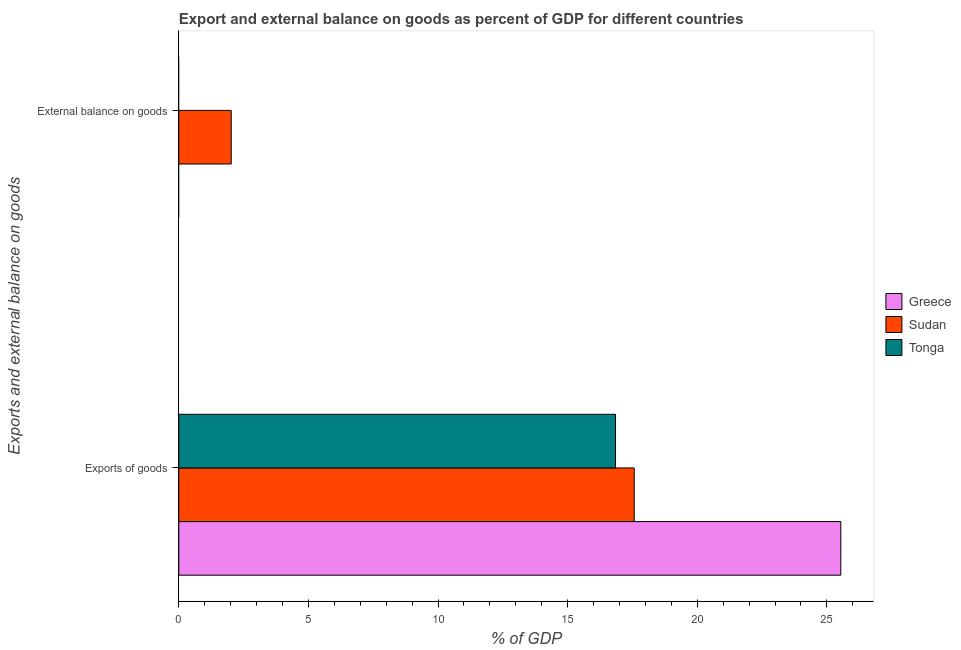Are the number of bars per tick equal to the number of legend labels?
Offer a very short reply. No. How many bars are there on the 2nd tick from the top?
Provide a short and direct response. 3. How many bars are there on the 1st tick from the bottom?
Give a very brief answer. 3. What is the label of the 1st group of bars from the top?
Keep it short and to the point. External balance on goods. What is the external balance on goods as percentage of gdp in Sudan?
Your answer should be very brief. 2.02. Across all countries, what is the maximum external balance on goods as percentage of gdp?
Make the answer very short. 2.02. Across all countries, what is the minimum export of goods as percentage of gdp?
Your answer should be compact. 16.85. In which country was the export of goods as percentage of gdp maximum?
Your answer should be very brief. Greece. What is the total external balance on goods as percentage of gdp in the graph?
Give a very brief answer. 2.02. What is the difference between the export of goods as percentage of gdp in Greece and that in Tonga?
Offer a terse response. 8.69. What is the difference between the export of goods as percentage of gdp in Tonga and the external balance on goods as percentage of gdp in Sudan?
Provide a short and direct response. 14.82. What is the average export of goods as percentage of gdp per country?
Offer a very short reply. 19.98. What is the difference between the external balance on goods as percentage of gdp and export of goods as percentage of gdp in Sudan?
Ensure brevity in your answer.  -15.54. In how many countries, is the external balance on goods as percentage of gdp greater than 18 %?
Offer a very short reply. 0. What is the ratio of the export of goods as percentage of gdp in Sudan to that in Greece?
Provide a short and direct response. 0.69. Are all the bars in the graph horizontal?
Provide a succinct answer. Yes. What is the difference between two consecutive major ticks on the X-axis?
Offer a very short reply. 5. Are the values on the major ticks of X-axis written in scientific E-notation?
Provide a succinct answer. No. Does the graph contain any zero values?
Make the answer very short. Yes. Where does the legend appear in the graph?
Give a very brief answer. Center right. How are the legend labels stacked?
Offer a terse response. Vertical. What is the title of the graph?
Offer a terse response. Export and external balance on goods as percent of GDP for different countries. What is the label or title of the X-axis?
Provide a short and direct response. % of GDP. What is the label or title of the Y-axis?
Offer a terse response. Exports and external balance on goods. What is the % of GDP in Greece in Exports of goods?
Your response must be concise. 25.54. What is the % of GDP of Sudan in Exports of goods?
Ensure brevity in your answer.  17.57. What is the % of GDP in Tonga in Exports of goods?
Your answer should be compact. 16.85. What is the % of GDP of Sudan in External balance on goods?
Keep it short and to the point. 2.02. What is the % of GDP of Tonga in External balance on goods?
Give a very brief answer. 0. Across all Exports and external balance on goods, what is the maximum % of GDP in Greece?
Provide a short and direct response. 25.54. Across all Exports and external balance on goods, what is the maximum % of GDP of Sudan?
Your answer should be compact. 17.57. Across all Exports and external balance on goods, what is the maximum % of GDP of Tonga?
Your response must be concise. 16.85. Across all Exports and external balance on goods, what is the minimum % of GDP in Greece?
Make the answer very short. 0. Across all Exports and external balance on goods, what is the minimum % of GDP in Sudan?
Your answer should be very brief. 2.02. What is the total % of GDP of Greece in the graph?
Your answer should be compact. 25.54. What is the total % of GDP of Sudan in the graph?
Ensure brevity in your answer.  19.59. What is the total % of GDP in Tonga in the graph?
Give a very brief answer. 16.85. What is the difference between the % of GDP in Sudan in Exports of goods and that in External balance on goods?
Ensure brevity in your answer.  15.54. What is the difference between the % of GDP in Greece in Exports of goods and the % of GDP in Sudan in External balance on goods?
Keep it short and to the point. 23.51. What is the average % of GDP of Greece per Exports and external balance on goods?
Your response must be concise. 12.77. What is the average % of GDP in Sudan per Exports and external balance on goods?
Give a very brief answer. 9.8. What is the average % of GDP in Tonga per Exports and external balance on goods?
Provide a short and direct response. 8.42. What is the difference between the % of GDP of Greece and % of GDP of Sudan in Exports of goods?
Offer a terse response. 7.97. What is the difference between the % of GDP of Greece and % of GDP of Tonga in Exports of goods?
Provide a succinct answer. 8.69. What is the difference between the % of GDP of Sudan and % of GDP of Tonga in Exports of goods?
Keep it short and to the point. 0.72. What is the ratio of the % of GDP in Sudan in Exports of goods to that in External balance on goods?
Offer a very short reply. 8.68. What is the difference between the highest and the second highest % of GDP of Sudan?
Offer a very short reply. 15.54. What is the difference between the highest and the lowest % of GDP of Greece?
Ensure brevity in your answer.  25.54. What is the difference between the highest and the lowest % of GDP of Sudan?
Offer a very short reply. 15.54. What is the difference between the highest and the lowest % of GDP of Tonga?
Your answer should be compact. 16.85. 